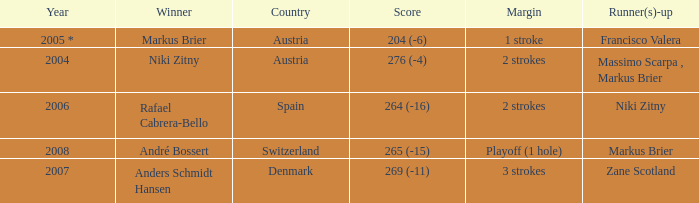In what year was the score 204 (-6)? 2005 *. 